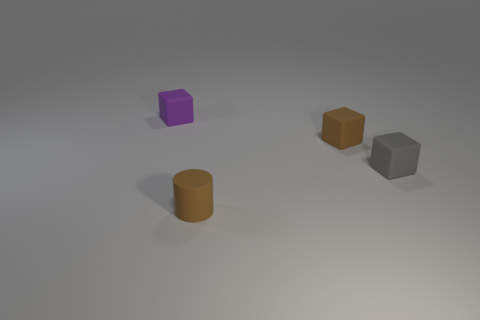There is a brown object behind the gray rubber block; is its size the same as the thing that is in front of the tiny gray block? Upon observing the image, the brown cylinder behind the gray cube appears to be larger in size compared to the purple cube, which is in front of the small gray cube. Although perspective might affect the appearance of size, the brown cylinder has a visibly greater height and diameter. 